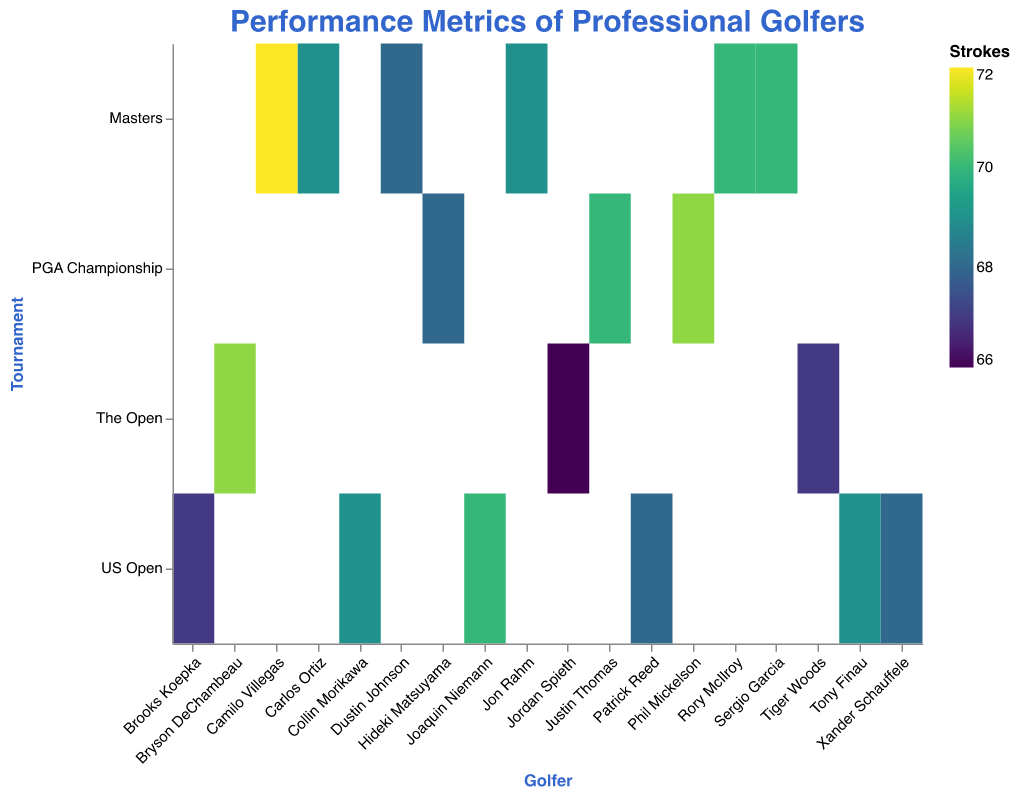What is the title of the figure? The title is typically found at the top of the visualization, specifying what the data represents.
Answer: "Performance Metrics of Professional Golfers" Which golfer performed best at The Open in Round 4 based on strokes? Look at the data for The Open in Round 4 and identify the golfer with the lowest stroke count.
Answer: Jordan Spieth How many rounds are represented in the Masters Tournament? For the Masters, count the unique rounds present in the visualization.
Answer: 2 What is the range of strokes among the golfers in the PGA Championship, Round 3? Identify the highest and lowest stroke counts in PGA Championship Round 3 and find the difference.
Answer: 71 - 68 = 3 Which golfer had the best scrambling percentage in the dataset? Look for the golfer with the highest scrambling percentage in the tooltip data.
Answer: Jordan Spieth with 87.0% Compare the strokes between Dustin Johnson in Masters Round 1 and Brooks Koepka in US Open Round 2. Who had the lower score? Identify and compare the strokes data for both golfers mentioned.
Answer: Brooks Koepka had the lower score with 67 strokes Which golfer had the highest number of putts in the dataset? Look at the tooltip data for putts and find the maximum value.
Answer: Phil Mickelson with 31 putts Who hit the most fairways in US Open Round 1? Compare the Fairways Hit data for golfers in US Open Round 1.
Answer: Patrick Reed with 12 fairways hit What is the average Greens in Regulation (GIR) for golfers in Masters Round 4? Sum up the GIR values for all golfers in Masters Round 4 and divide by the number of golfers. (12 + 14 + 11) / 3 = 12.33
Answer: 12.33 In which tournament and round did Carlos Ortiz play? Refer to the tooltip data to locate Carlos Ortiz and note the corresponding tournament and round.
Answer: Masters, Round 4 